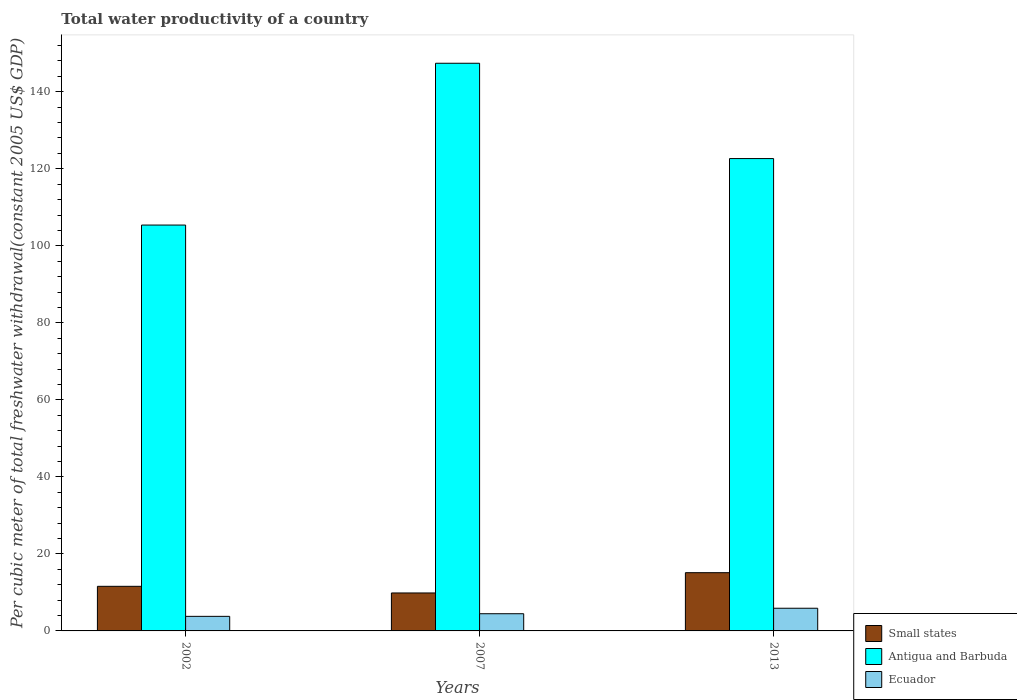How many different coloured bars are there?
Make the answer very short. 3. How many groups of bars are there?
Your response must be concise. 3. Are the number of bars per tick equal to the number of legend labels?
Provide a short and direct response. Yes. Are the number of bars on each tick of the X-axis equal?
Provide a short and direct response. Yes. How many bars are there on the 2nd tick from the left?
Your answer should be compact. 3. In how many cases, is the number of bars for a given year not equal to the number of legend labels?
Your answer should be very brief. 0. What is the total water productivity in Small states in 2007?
Keep it short and to the point. 9.86. Across all years, what is the maximum total water productivity in Small states?
Give a very brief answer. 15.12. Across all years, what is the minimum total water productivity in Ecuador?
Offer a terse response. 3.79. In which year was the total water productivity in Small states maximum?
Offer a terse response. 2013. What is the total total water productivity in Ecuador in the graph?
Your answer should be compact. 14.14. What is the difference between the total water productivity in Ecuador in 2007 and that in 2013?
Offer a terse response. -1.43. What is the difference between the total water productivity in Antigua and Barbuda in 2007 and the total water productivity in Ecuador in 2013?
Provide a succinct answer. 141.51. What is the average total water productivity in Small states per year?
Make the answer very short. 12.19. In the year 2002, what is the difference between the total water productivity in Ecuador and total water productivity in Small states?
Your answer should be very brief. -7.8. What is the ratio of the total water productivity in Small states in 2007 to that in 2013?
Your answer should be very brief. 0.65. Is the total water productivity in Ecuador in 2002 less than that in 2013?
Your answer should be very brief. Yes. What is the difference between the highest and the second highest total water productivity in Antigua and Barbuda?
Keep it short and to the point. 24.75. What is the difference between the highest and the lowest total water productivity in Ecuador?
Your answer should be compact. 2.11. What does the 2nd bar from the left in 2007 represents?
Ensure brevity in your answer.  Antigua and Barbuda. What does the 1st bar from the right in 2002 represents?
Ensure brevity in your answer.  Ecuador. Is it the case that in every year, the sum of the total water productivity in Ecuador and total water productivity in Antigua and Barbuda is greater than the total water productivity in Small states?
Keep it short and to the point. Yes. How many bars are there?
Make the answer very short. 9. Are all the bars in the graph horizontal?
Provide a succinct answer. No. How many years are there in the graph?
Your response must be concise. 3. Are the values on the major ticks of Y-axis written in scientific E-notation?
Give a very brief answer. No. Does the graph contain any zero values?
Your response must be concise. No. Does the graph contain grids?
Your response must be concise. No. Where does the legend appear in the graph?
Your response must be concise. Bottom right. How many legend labels are there?
Give a very brief answer. 3. How are the legend labels stacked?
Offer a very short reply. Vertical. What is the title of the graph?
Make the answer very short. Total water productivity of a country. Does "Rwanda" appear as one of the legend labels in the graph?
Provide a succinct answer. No. What is the label or title of the Y-axis?
Keep it short and to the point. Per cubic meter of total freshwater withdrawal(constant 2005 US$ GDP). What is the Per cubic meter of total freshwater withdrawal(constant 2005 US$ GDP) in Small states in 2002?
Make the answer very short. 11.58. What is the Per cubic meter of total freshwater withdrawal(constant 2005 US$ GDP) of Antigua and Barbuda in 2002?
Make the answer very short. 105.39. What is the Per cubic meter of total freshwater withdrawal(constant 2005 US$ GDP) in Ecuador in 2002?
Provide a short and direct response. 3.79. What is the Per cubic meter of total freshwater withdrawal(constant 2005 US$ GDP) in Small states in 2007?
Provide a short and direct response. 9.86. What is the Per cubic meter of total freshwater withdrawal(constant 2005 US$ GDP) in Antigua and Barbuda in 2007?
Give a very brief answer. 147.4. What is the Per cubic meter of total freshwater withdrawal(constant 2005 US$ GDP) of Ecuador in 2007?
Your answer should be very brief. 4.47. What is the Per cubic meter of total freshwater withdrawal(constant 2005 US$ GDP) in Small states in 2013?
Offer a very short reply. 15.12. What is the Per cubic meter of total freshwater withdrawal(constant 2005 US$ GDP) of Antigua and Barbuda in 2013?
Keep it short and to the point. 122.66. What is the Per cubic meter of total freshwater withdrawal(constant 2005 US$ GDP) in Ecuador in 2013?
Provide a succinct answer. 5.89. Across all years, what is the maximum Per cubic meter of total freshwater withdrawal(constant 2005 US$ GDP) in Small states?
Give a very brief answer. 15.12. Across all years, what is the maximum Per cubic meter of total freshwater withdrawal(constant 2005 US$ GDP) of Antigua and Barbuda?
Your response must be concise. 147.4. Across all years, what is the maximum Per cubic meter of total freshwater withdrawal(constant 2005 US$ GDP) of Ecuador?
Give a very brief answer. 5.89. Across all years, what is the minimum Per cubic meter of total freshwater withdrawal(constant 2005 US$ GDP) in Small states?
Your response must be concise. 9.86. Across all years, what is the minimum Per cubic meter of total freshwater withdrawal(constant 2005 US$ GDP) of Antigua and Barbuda?
Offer a terse response. 105.39. Across all years, what is the minimum Per cubic meter of total freshwater withdrawal(constant 2005 US$ GDP) in Ecuador?
Ensure brevity in your answer.  3.79. What is the total Per cubic meter of total freshwater withdrawal(constant 2005 US$ GDP) of Small states in the graph?
Your answer should be very brief. 36.56. What is the total Per cubic meter of total freshwater withdrawal(constant 2005 US$ GDP) of Antigua and Barbuda in the graph?
Ensure brevity in your answer.  375.45. What is the total Per cubic meter of total freshwater withdrawal(constant 2005 US$ GDP) of Ecuador in the graph?
Ensure brevity in your answer.  14.14. What is the difference between the Per cubic meter of total freshwater withdrawal(constant 2005 US$ GDP) of Small states in 2002 and that in 2007?
Your answer should be compact. 1.73. What is the difference between the Per cubic meter of total freshwater withdrawal(constant 2005 US$ GDP) in Antigua and Barbuda in 2002 and that in 2007?
Keep it short and to the point. -42.02. What is the difference between the Per cubic meter of total freshwater withdrawal(constant 2005 US$ GDP) of Ecuador in 2002 and that in 2007?
Your answer should be very brief. -0.68. What is the difference between the Per cubic meter of total freshwater withdrawal(constant 2005 US$ GDP) of Small states in 2002 and that in 2013?
Your answer should be compact. -3.54. What is the difference between the Per cubic meter of total freshwater withdrawal(constant 2005 US$ GDP) in Antigua and Barbuda in 2002 and that in 2013?
Your response must be concise. -17.27. What is the difference between the Per cubic meter of total freshwater withdrawal(constant 2005 US$ GDP) of Ecuador in 2002 and that in 2013?
Give a very brief answer. -2.11. What is the difference between the Per cubic meter of total freshwater withdrawal(constant 2005 US$ GDP) of Small states in 2007 and that in 2013?
Offer a terse response. -5.27. What is the difference between the Per cubic meter of total freshwater withdrawal(constant 2005 US$ GDP) in Antigua and Barbuda in 2007 and that in 2013?
Give a very brief answer. 24.75. What is the difference between the Per cubic meter of total freshwater withdrawal(constant 2005 US$ GDP) in Ecuador in 2007 and that in 2013?
Ensure brevity in your answer.  -1.43. What is the difference between the Per cubic meter of total freshwater withdrawal(constant 2005 US$ GDP) of Small states in 2002 and the Per cubic meter of total freshwater withdrawal(constant 2005 US$ GDP) of Antigua and Barbuda in 2007?
Provide a succinct answer. -135.82. What is the difference between the Per cubic meter of total freshwater withdrawal(constant 2005 US$ GDP) in Small states in 2002 and the Per cubic meter of total freshwater withdrawal(constant 2005 US$ GDP) in Ecuador in 2007?
Your response must be concise. 7.12. What is the difference between the Per cubic meter of total freshwater withdrawal(constant 2005 US$ GDP) of Antigua and Barbuda in 2002 and the Per cubic meter of total freshwater withdrawal(constant 2005 US$ GDP) of Ecuador in 2007?
Offer a terse response. 100.92. What is the difference between the Per cubic meter of total freshwater withdrawal(constant 2005 US$ GDP) in Small states in 2002 and the Per cubic meter of total freshwater withdrawal(constant 2005 US$ GDP) in Antigua and Barbuda in 2013?
Your answer should be compact. -111.07. What is the difference between the Per cubic meter of total freshwater withdrawal(constant 2005 US$ GDP) of Small states in 2002 and the Per cubic meter of total freshwater withdrawal(constant 2005 US$ GDP) of Ecuador in 2013?
Offer a terse response. 5.69. What is the difference between the Per cubic meter of total freshwater withdrawal(constant 2005 US$ GDP) of Antigua and Barbuda in 2002 and the Per cubic meter of total freshwater withdrawal(constant 2005 US$ GDP) of Ecuador in 2013?
Offer a very short reply. 99.5. What is the difference between the Per cubic meter of total freshwater withdrawal(constant 2005 US$ GDP) of Small states in 2007 and the Per cubic meter of total freshwater withdrawal(constant 2005 US$ GDP) of Antigua and Barbuda in 2013?
Ensure brevity in your answer.  -112.8. What is the difference between the Per cubic meter of total freshwater withdrawal(constant 2005 US$ GDP) of Small states in 2007 and the Per cubic meter of total freshwater withdrawal(constant 2005 US$ GDP) of Ecuador in 2013?
Your response must be concise. 3.97. What is the difference between the Per cubic meter of total freshwater withdrawal(constant 2005 US$ GDP) in Antigua and Barbuda in 2007 and the Per cubic meter of total freshwater withdrawal(constant 2005 US$ GDP) in Ecuador in 2013?
Keep it short and to the point. 141.51. What is the average Per cubic meter of total freshwater withdrawal(constant 2005 US$ GDP) of Small states per year?
Your answer should be compact. 12.19. What is the average Per cubic meter of total freshwater withdrawal(constant 2005 US$ GDP) of Antigua and Barbuda per year?
Offer a very short reply. 125.15. What is the average Per cubic meter of total freshwater withdrawal(constant 2005 US$ GDP) of Ecuador per year?
Your answer should be very brief. 4.71. In the year 2002, what is the difference between the Per cubic meter of total freshwater withdrawal(constant 2005 US$ GDP) in Small states and Per cubic meter of total freshwater withdrawal(constant 2005 US$ GDP) in Antigua and Barbuda?
Keep it short and to the point. -93.81. In the year 2002, what is the difference between the Per cubic meter of total freshwater withdrawal(constant 2005 US$ GDP) of Small states and Per cubic meter of total freshwater withdrawal(constant 2005 US$ GDP) of Ecuador?
Offer a very short reply. 7.8. In the year 2002, what is the difference between the Per cubic meter of total freshwater withdrawal(constant 2005 US$ GDP) of Antigua and Barbuda and Per cubic meter of total freshwater withdrawal(constant 2005 US$ GDP) of Ecuador?
Ensure brevity in your answer.  101.6. In the year 2007, what is the difference between the Per cubic meter of total freshwater withdrawal(constant 2005 US$ GDP) of Small states and Per cubic meter of total freshwater withdrawal(constant 2005 US$ GDP) of Antigua and Barbuda?
Your answer should be compact. -137.55. In the year 2007, what is the difference between the Per cubic meter of total freshwater withdrawal(constant 2005 US$ GDP) of Small states and Per cubic meter of total freshwater withdrawal(constant 2005 US$ GDP) of Ecuador?
Your answer should be compact. 5.39. In the year 2007, what is the difference between the Per cubic meter of total freshwater withdrawal(constant 2005 US$ GDP) of Antigua and Barbuda and Per cubic meter of total freshwater withdrawal(constant 2005 US$ GDP) of Ecuador?
Provide a short and direct response. 142.94. In the year 2013, what is the difference between the Per cubic meter of total freshwater withdrawal(constant 2005 US$ GDP) of Small states and Per cubic meter of total freshwater withdrawal(constant 2005 US$ GDP) of Antigua and Barbuda?
Make the answer very short. -107.53. In the year 2013, what is the difference between the Per cubic meter of total freshwater withdrawal(constant 2005 US$ GDP) of Small states and Per cubic meter of total freshwater withdrawal(constant 2005 US$ GDP) of Ecuador?
Your answer should be very brief. 9.23. In the year 2013, what is the difference between the Per cubic meter of total freshwater withdrawal(constant 2005 US$ GDP) of Antigua and Barbuda and Per cubic meter of total freshwater withdrawal(constant 2005 US$ GDP) of Ecuador?
Offer a very short reply. 116.77. What is the ratio of the Per cubic meter of total freshwater withdrawal(constant 2005 US$ GDP) in Small states in 2002 to that in 2007?
Keep it short and to the point. 1.18. What is the ratio of the Per cubic meter of total freshwater withdrawal(constant 2005 US$ GDP) of Antigua and Barbuda in 2002 to that in 2007?
Your answer should be very brief. 0.71. What is the ratio of the Per cubic meter of total freshwater withdrawal(constant 2005 US$ GDP) of Ecuador in 2002 to that in 2007?
Make the answer very short. 0.85. What is the ratio of the Per cubic meter of total freshwater withdrawal(constant 2005 US$ GDP) of Small states in 2002 to that in 2013?
Your response must be concise. 0.77. What is the ratio of the Per cubic meter of total freshwater withdrawal(constant 2005 US$ GDP) of Antigua and Barbuda in 2002 to that in 2013?
Provide a succinct answer. 0.86. What is the ratio of the Per cubic meter of total freshwater withdrawal(constant 2005 US$ GDP) of Ecuador in 2002 to that in 2013?
Give a very brief answer. 0.64. What is the ratio of the Per cubic meter of total freshwater withdrawal(constant 2005 US$ GDP) of Small states in 2007 to that in 2013?
Offer a terse response. 0.65. What is the ratio of the Per cubic meter of total freshwater withdrawal(constant 2005 US$ GDP) of Antigua and Barbuda in 2007 to that in 2013?
Ensure brevity in your answer.  1.2. What is the ratio of the Per cubic meter of total freshwater withdrawal(constant 2005 US$ GDP) of Ecuador in 2007 to that in 2013?
Offer a very short reply. 0.76. What is the difference between the highest and the second highest Per cubic meter of total freshwater withdrawal(constant 2005 US$ GDP) in Small states?
Make the answer very short. 3.54. What is the difference between the highest and the second highest Per cubic meter of total freshwater withdrawal(constant 2005 US$ GDP) in Antigua and Barbuda?
Offer a terse response. 24.75. What is the difference between the highest and the second highest Per cubic meter of total freshwater withdrawal(constant 2005 US$ GDP) in Ecuador?
Offer a very short reply. 1.43. What is the difference between the highest and the lowest Per cubic meter of total freshwater withdrawal(constant 2005 US$ GDP) in Small states?
Keep it short and to the point. 5.27. What is the difference between the highest and the lowest Per cubic meter of total freshwater withdrawal(constant 2005 US$ GDP) of Antigua and Barbuda?
Your answer should be very brief. 42.02. What is the difference between the highest and the lowest Per cubic meter of total freshwater withdrawal(constant 2005 US$ GDP) in Ecuador?
Offer a terse response. 2.11. 